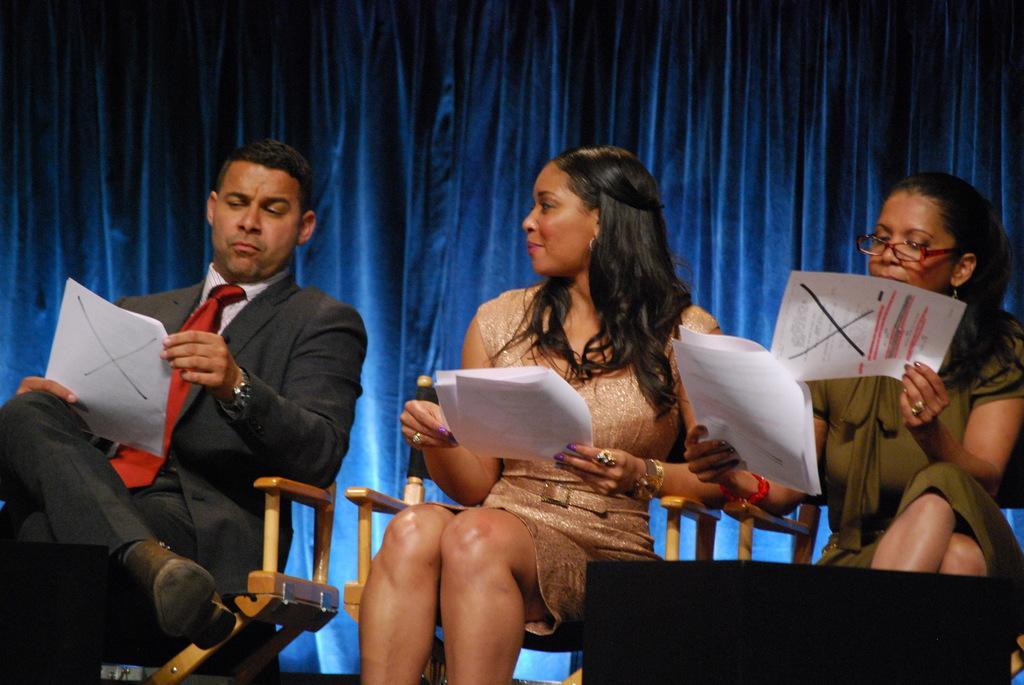Could you give a brief overview of what you see in this image? In the picture I can see a man sitting on the chair and he is holding the paper in his hand. He is wearing a suit and a tie. I can see two women sitting on the chairs and they are also holding the papers in their hands. In the background, I can see the curtain. 